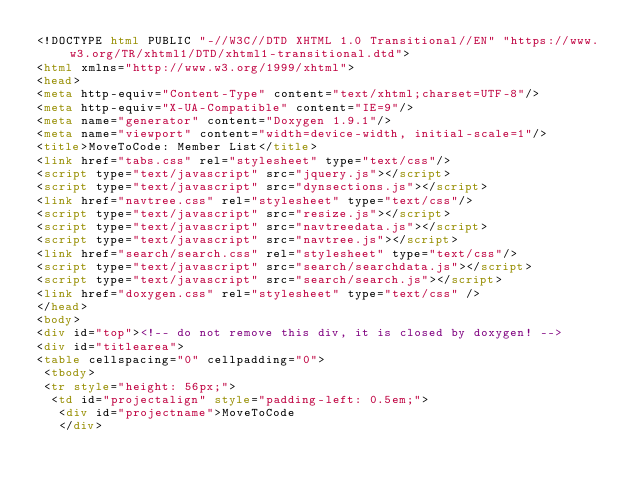Convert code to text. <code><loc_0><loc_0><loc_500><loc_500><_HTML_><!DOCTYPE html PUBLIC "-//W3C//DTD XHTML 1.0 Transitional//EN" "https://www.w3.org/TR/xhtml1/DTD/xhtml1-transitional.dtd">
<html xmlns="http://www.w3.org/1999/xhtml">
<head>
<meta http-equiv="Content-Type" content="text/xhtml;charset=UTF-8"/>
<meta http-equiv="X-UA-Compatible" content="IE=9"/>
<meta name="generator" content="Doxygen 1.9.1"/>
<meta name="viewport" content="width=device-width, initial-scale=1"/>
<title>MoveToCode: Member List</title>
<link href="tabs.css" rel="stylesheet" type="text/css"/>
<script type="text/javascript" src="jquery.js"></script>
<script type="text/javascript" src="dynsections.js"></script>
<link href="navtree.css" rel="stylesheet" type="text/css"/>
<script type="text/javascript" src="resize.js"></script>
<script type="text/javascript" src="navtreedata.js"></script>
<script type="text/javascript" src="navtree.js"></script>
<link href="search/search.css" rel="stylesheet" type="text/css"/>
<script type="text/javascript" src="search/searchdata.js"></script>
<script type="text/javascript" src="search/search.js"></script>
<link href="doxygen.css" rel="stylesheet" type="text/css" />
</head>
<body>
<div id="top"><!-- do not remove this div, it is closed by doxygen! -->
<div id="titlearea">
<table cellspacing="0" cellpadding="0">
 <tbody>
 <tr style="height: 56px;">
  <td id="projectalign" style="padding-left: 0.5em;">
   <div id="projectname">MoveToCode
   </div></code> 